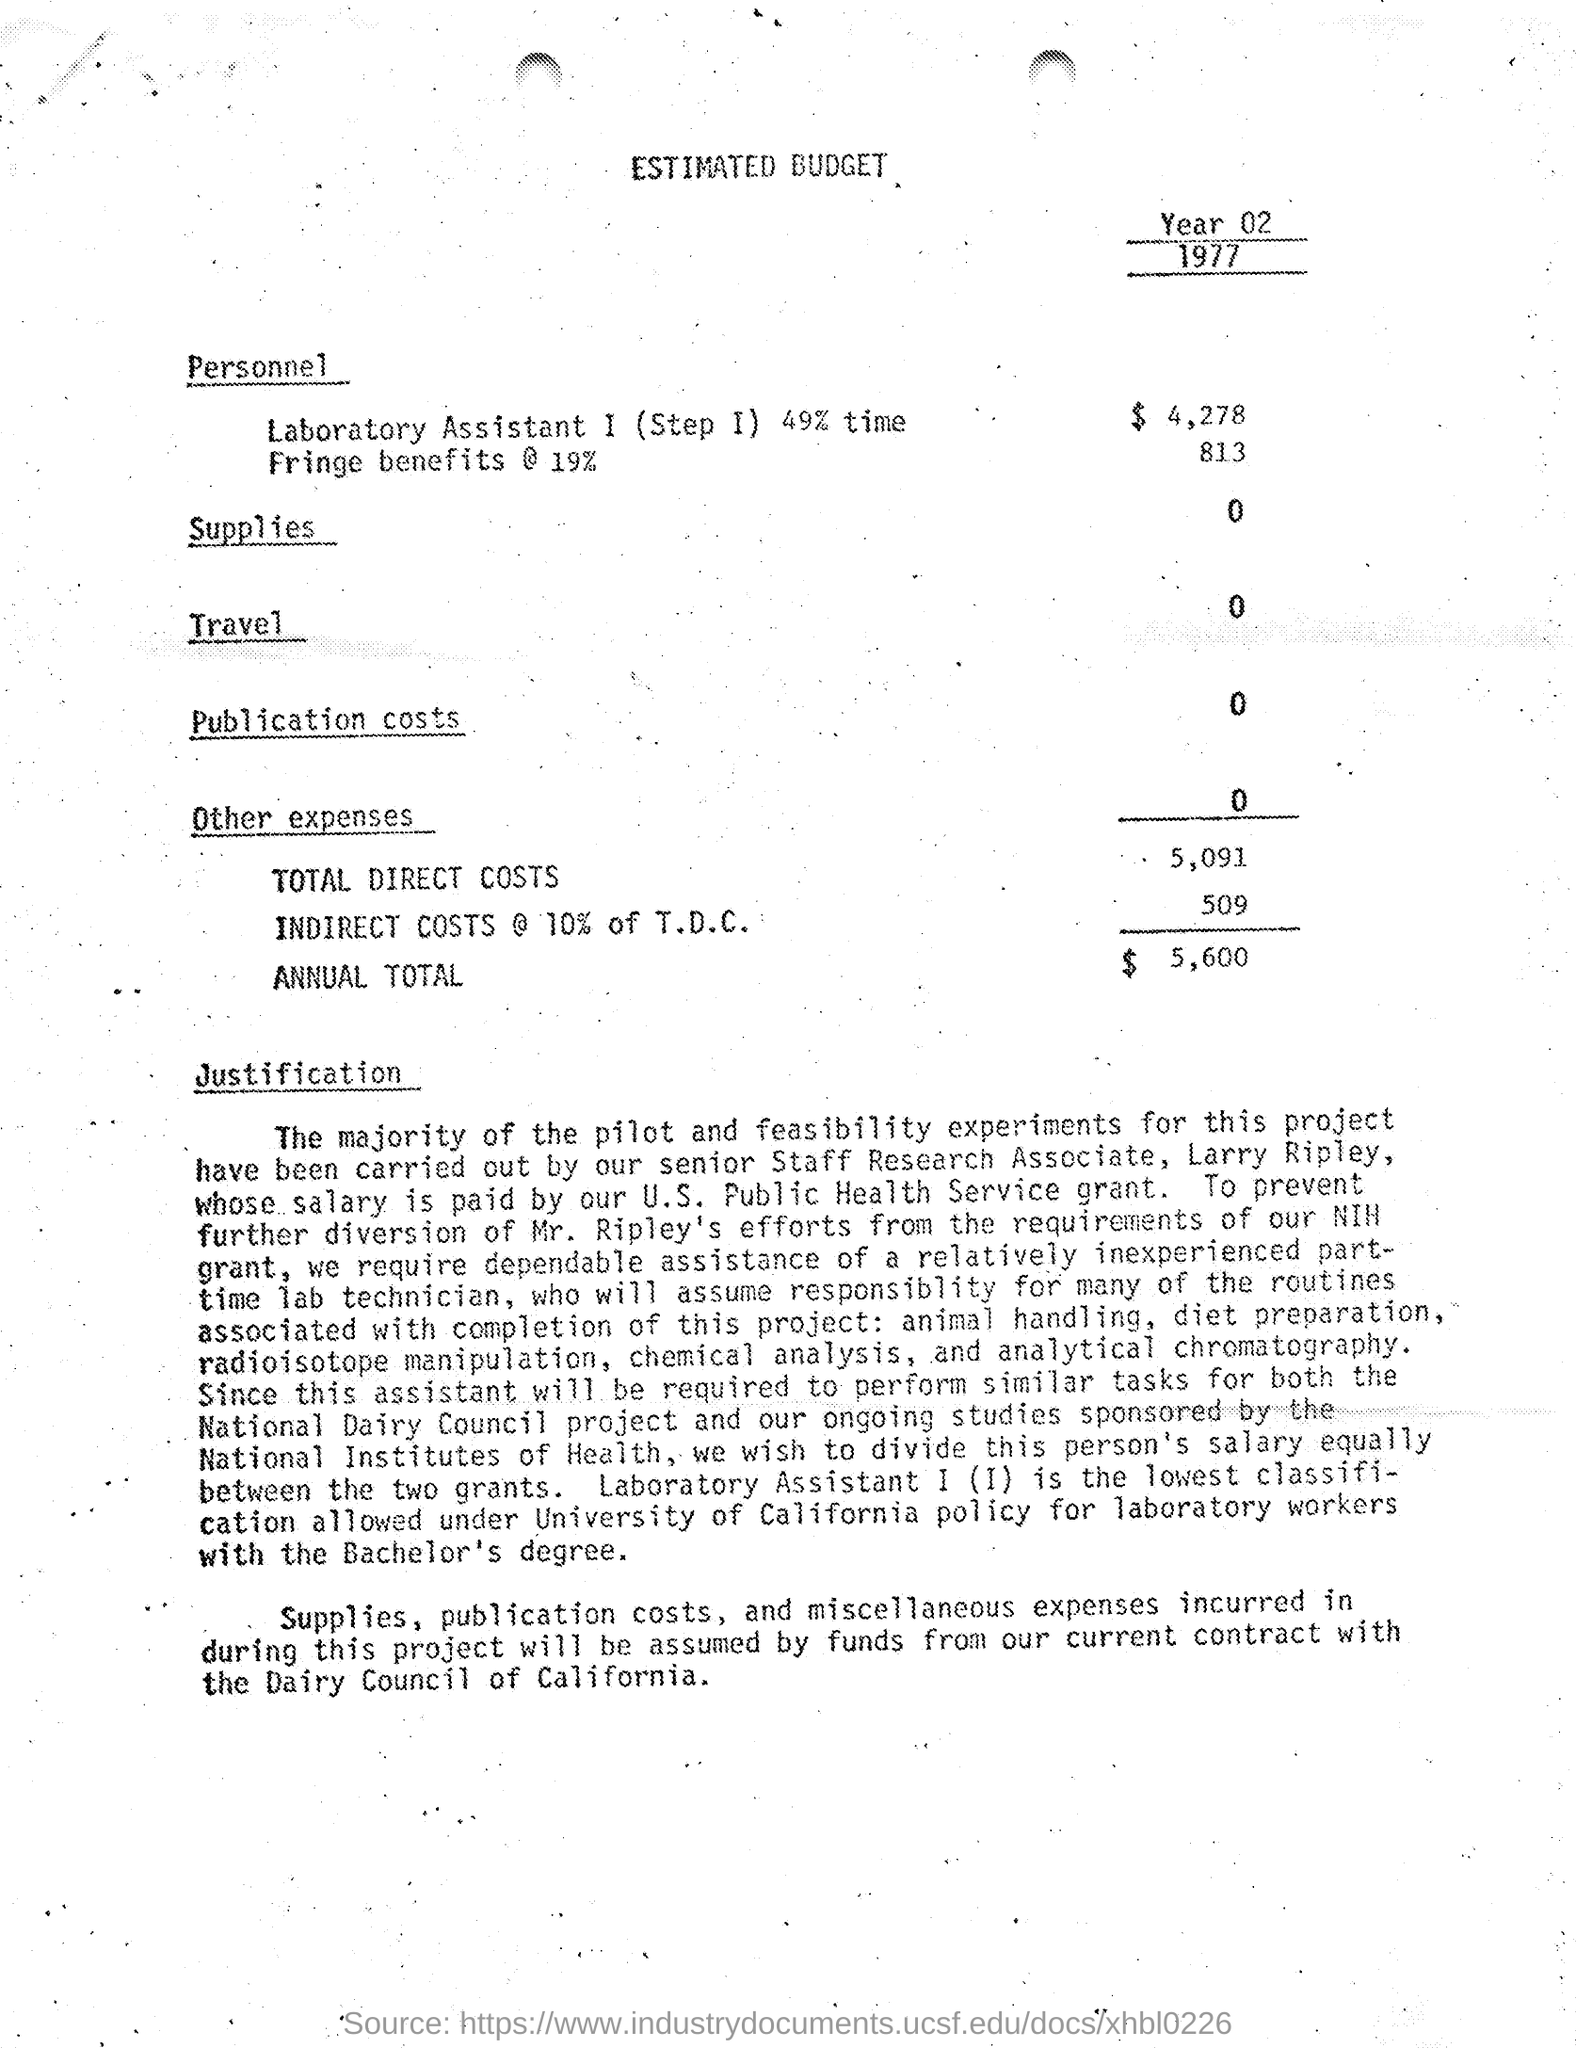Identify some key points in this picture. The amount of indirect costs mentioned in the given budget is 509. The total direct costs mentioned in the given budget are 5,091. The estimated budget provides an amount for supplies, with no specified range. The amount of publication costs mentioned in the estimated budget is 0. The amount allocated for Laboratory Assistant 1 in the estimated budget is $4,278. 